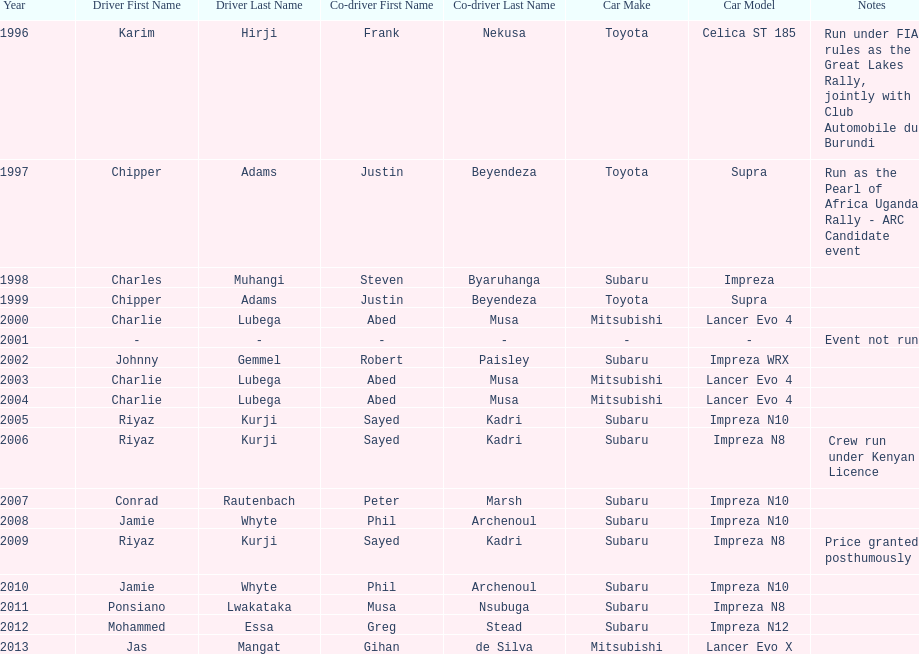Who was the only driver to win in a car other than a subaru impreza after the year 2005? Jas Mangat. 